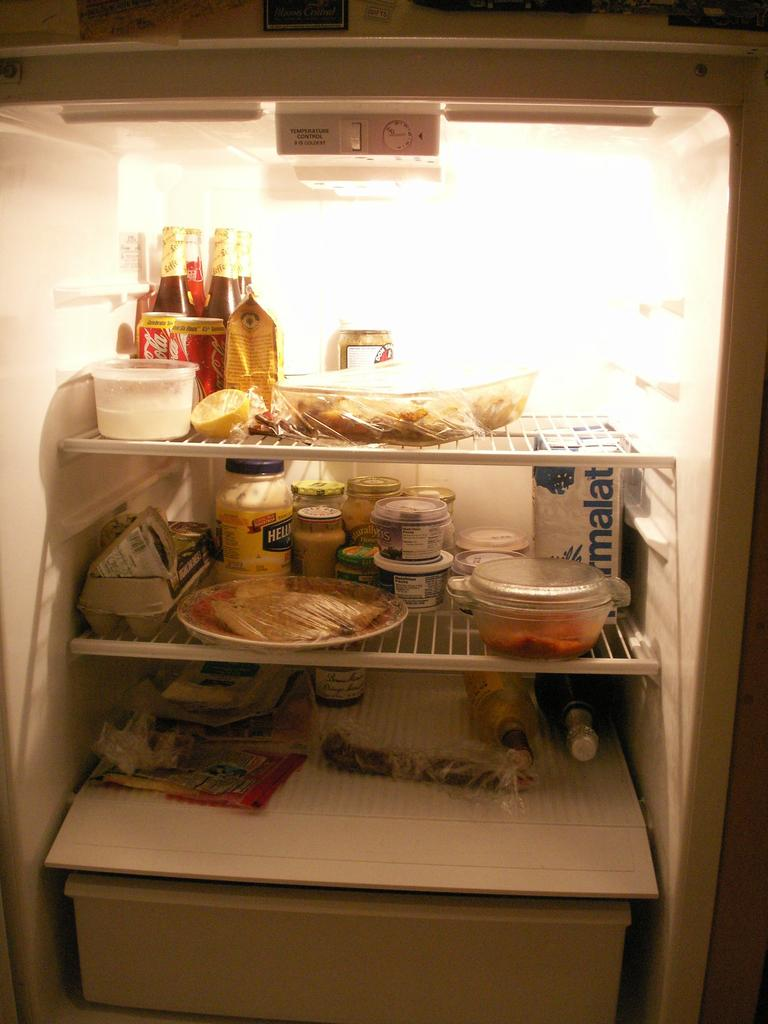<image>
Share a concise interpretation of the image provided. The inside of a fridge with many things such as coca cola cans inside. 